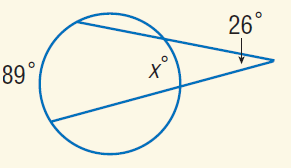Question: Find x.
Choices:
A. 26
B. 37
C. 80
D. 89
Answer with the letter. Answer: B 